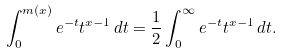<formula> <loc_0><loc_0><loc_500><loc_500>\int _ { 0 } ^ { m ( x ) } e ^ { - t } t ^ { x - 1 } \, d t = \frac { 1 } { 2 } \int _ { 0 } ^ { \infty } e ^ { - t } t ^ { x - 1 } \, d t .</formula> 